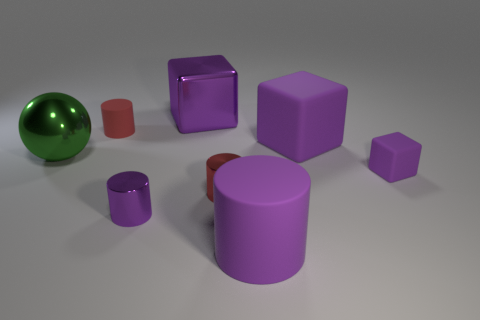Subtract all yellow balls. How many purple cylinders are left? 2 Subtract all metallic blocks. How many blocks are left? 2 Add 2 small red rubber things. How many objects exist? 10 Subtract all purple cylinders. How many cylinders are left? 2 Subtract all spheres. How many objects are left? 7 Add 6 purple rubber cylinders. How many purple rubber cylinders are left? 7 Add 1 small red shiny cylinders. How many small red shiny cylinders exist? 2 Subtract 0 blue cubes. How many objects are left? 8 Subtract all blue cylinders. Subtract all blue balls. How many cylinders are left? 4 Subtract all tiny purple metal things. Subtract all small purple matte cubes. How many objects are left? 6 